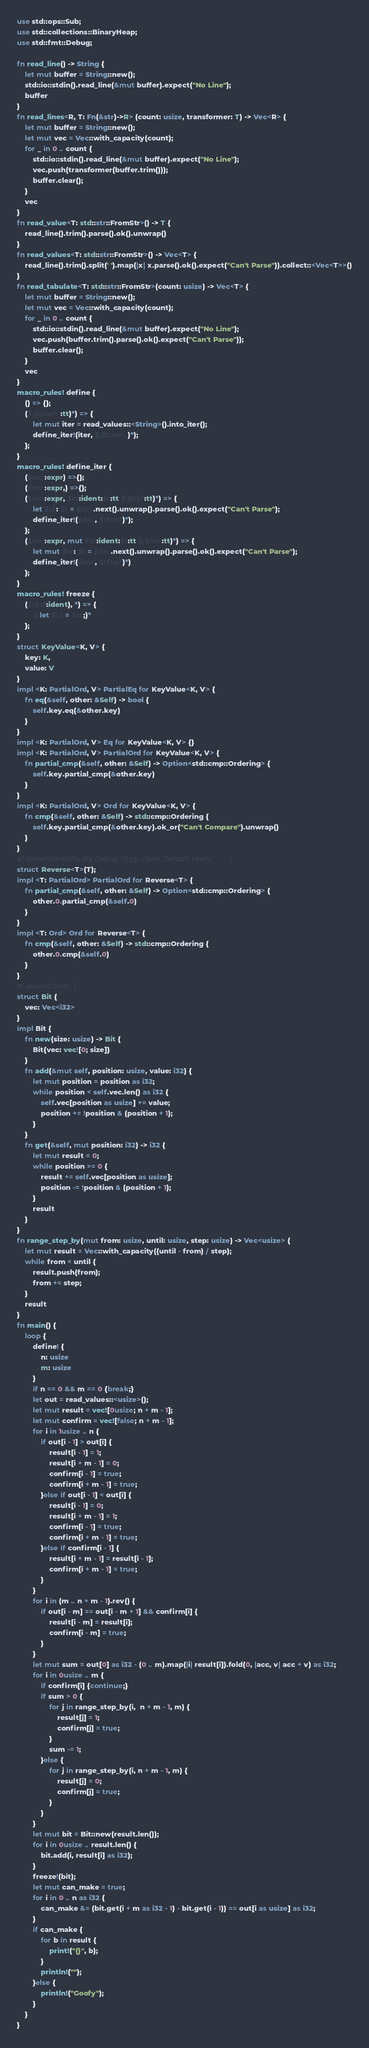<code> <loc_0><loc_0><loc_500><loc_500><_Rust_>use std::ops::Sub;
use std::collections::BinaryHeap;
use std::fmt::Debug;

fn read_line() -> String {
    let mut buffer = String::new();
    std::io::stdin().read_line(&mut buffer).expect("No Line");
    buffer
}
fn read_lines<R, T: Fn(&str)->R> (count: usize, transformer: T) -> Vec<R> {
    let mut buffer = String::new();
    let mut vec = Vec::with_capacity(count);
    for _ in 0 .. count {
        std::io::stdin().read_line(&mut buffer).expect("No Line");
        vec.push(transformer(buffer.trim()));
        buffer.clear();
    }
    vec
}
fn read_value<T: std::str::FromStr>() -> T {
    read_line().trim().parse().ok().unwrap()
}
fn read_values<T: std::str::FromStr>() -> Vec<T> {
    read_line().trim().split(' ').map(|x| x.parse().ok().expect("Can't Parse")).collect::<Vec<T>>()
}
fn read_tabulate<T: std::str::FromStr>(count: usize) -> Vec<T> {
    let mut buffer = String::new();
    let mut vec = Vec::with_capacity(count);
    for _ in 0 .. count {
        std::io::stdin().read_line(&mut buffer).expect("No Line");
        vec.push(buffer.trim().parse().ok().expect("Can't Parse"));
        buffer.clear();
    }
    vec
}
macro_rules! define {
    () => {};
    ($($token:tt)*) => {
        let mut iter = read_values::<String>().into_iter();
        define_iter!(iter, $($token)*);
    };
}
macro_rules! define_iter {
    ($iter:expr) =>{};
    ($iter:expr,) =>{};
    ($iter:expr, $id:ident:$t:tt $($tail:tt)*) => {
        let $id: $t = $iter.next().unwrap().parse().ok().expect("Can't Parse");
        define_iter!($iter, $($tail)*);
    };
    ($iter:expr, mut $id:ident:$t:tt $($tail:tt)*) => {
        let mut $id: $t = $iter.next().unwrap().parse().ok().expect("Can't Parse");
        define_iter!($iter, $($tail)*)
    };
}
macro_rules! freeze {
    ($($id:ident), *) => {
        $(let $id = $id;)*
    };
}
struct KeyValue<K, V> {
    key: K,
    value: V
}
impl <K: PartialOrd, V> PartialEq for KeyValue<K, V> {
    fn eq(&self, other: &Self) -> bool {
        self.key.eq(&other.key)
    }
}
impl <K: PartialOrd, V> Eq for KeyValue<K, V> {}
impl <K: PartialOrd, V> PartialOrd for KeyValue<K, V> {
    fn partial_cmp(&self, other: &Self) -> Option<std::cmp::Ordering> {
        self.key.partial_cmp(&other.key)
    }
}
impl <K: PartialOrd, V> Ord for KeyValue<K, V> {
    fn cmp(&self, other: &Self) -> std::cmp::Ordering {
        self.key.partial_cmp(&other.key).ok_or("Can't Compare").unwrap()
    }
} 
#[derive(PartialEq, Eq, Debug, Copy, Clone, Default, Hash)]
struct Reverse<T>(T);
impl <T: PartialOrd> PartialOrd for Reverse<T> {
    fn partial_cmp(&self, other: &Self) -> Option<std::cmp::Ordering> {
        other.0.partial_cmp(&self.0)
    }
}
impl <T: Ord> Ord for Reverse<T> {
    fn cmp(&self, other: &Self) -> std::cmp::Ordering {
        other.0.cmp(&self.0)
    }
}
#[derive(Clone)]
struct Bit {
    vec: Vec<i32>
}
impl Bit {
    fn new(size: usize) -> Bit {
        Bit{vec: vec![0; size]}
    }
    fn add(&mut self, position: usize, value: i32) {
        let mut position = position as i32;
        while position < self.vec.len() as i32 {
            self.vec[position as usize] += value;
            position += !position & (position + 1);
        }
    }
    fn get(&self, mut position: i32) -> i32 {
        let mut result = 0;
        while position >= 0 {
            result += self.vec[position as usize];
            position -= !position & (position + 1);
        }
        result
    }
}
fn range_step_by(mut from: usize, until: usize, step: usize) -> Vec<usize> {
    let mut result = Vec::with_capacity((until - from) / step);
    while from < until {
        result.push(from);
        from += step;
    }
    result
}
fn main() {
    loop {
        define! {
            n: usize
            m: usize
        }
        if n == 0 && m == 0 {break;}
        let out = read_values::<usize>();
        let mut result = vec![0usize; n + m - 1];
        let mut confirm = vec![false; n + m - 1];
        for i in 1usize .. n {
            if out[i - 1] > out[i] {
                result[i - 1] = 1;
                result[i + m - 1] = 0;
                confirm[i - 1] = true;
                confirm[i + m - 1] = true;
            }else if out[i - 1] < out[i] {
                result[i - 1] = 0;
                result[i + m - 1] = 1;
                confirm[i - 1] = true;
                confirm[i + m - 1] = true;
            }else if confirm[i - 1] {
                result[i + m - 1] = result[i - 1];
                confirm[i + m - 1] = true;
            }
        }
        for i in (m .. n + m - 1).rev() {
            if out[i - m] == out[i - m + 1] && confirm[i] {
                result[i - m] = result[i];
                confirm[i - m] = true;
            }
        }
        let mut sum = out[0] as i32 - (0 .. m).map(|i| result[i]).fold(0, |acc, v| acc + v) as i32;
        for i in 0usize .. m {
            if confirm[i] {continue;}
            if sum > 0 {
                for j in range_step_by(i,  n + m - 1, m) {
                    result[j] = 1;
                    confirm[j] = true;
                }
                sum -= 1;
            }else {
                for j in range_step_by(i, n + m - 1, m) {
                    result[j] = 0;
                    confirm[j] = true;
                }
            }
        }
        let mut bit = Bit::new(result.len());
        for i in 0usize .. result.len() {
            bit.add(i, result[i] as i32);
        }
        freeze!(bit);
        let mut can_make = true;
        for i in 0 .. n as i32 {
            can_make &= (bit.get(i + m as i32 - 1) - bit.get(i - 1)) == out[i as usize] as i32;
        }
        if can_make {
            for b in result {
                print!("{}", b);
            }
            println!("");
        }else {
            println!("Goofy");
        }
    }
}
</code> 